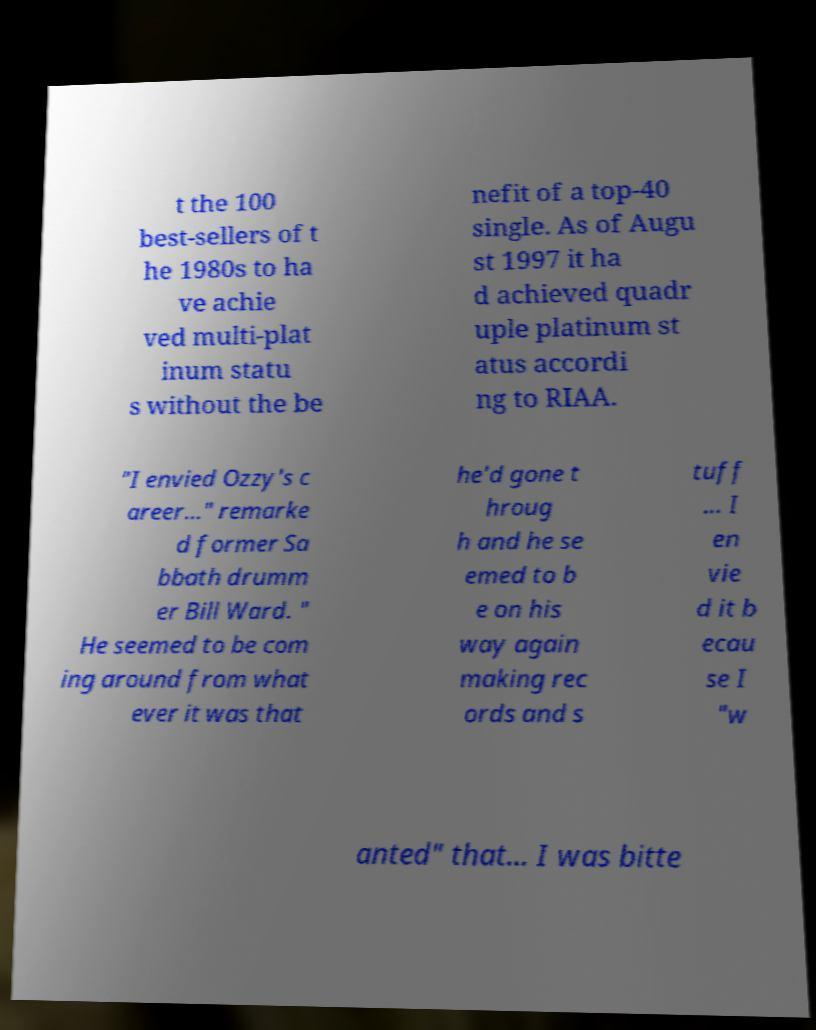Please read and relay the text visible in this image. What does it say? t the 100 best-sellers of t he 1980s to ha ve achie ved multi-plat inum statu s without the be nefit of a top-40 single. As of Augu st 1997 it ha d achieved quadr uple platinum st atus accordi ng to RIAA. "I envied Ozzy's c areer…" remarke d former Sa bbath drumm er Bill Ward. " He seemed to be com ing around from what ever it was that he'd gone t hroug h and he se emed to b e on his way again making rec ords and s tuff … I en vie d it b ecau se I "w anted" that… I was bitte 